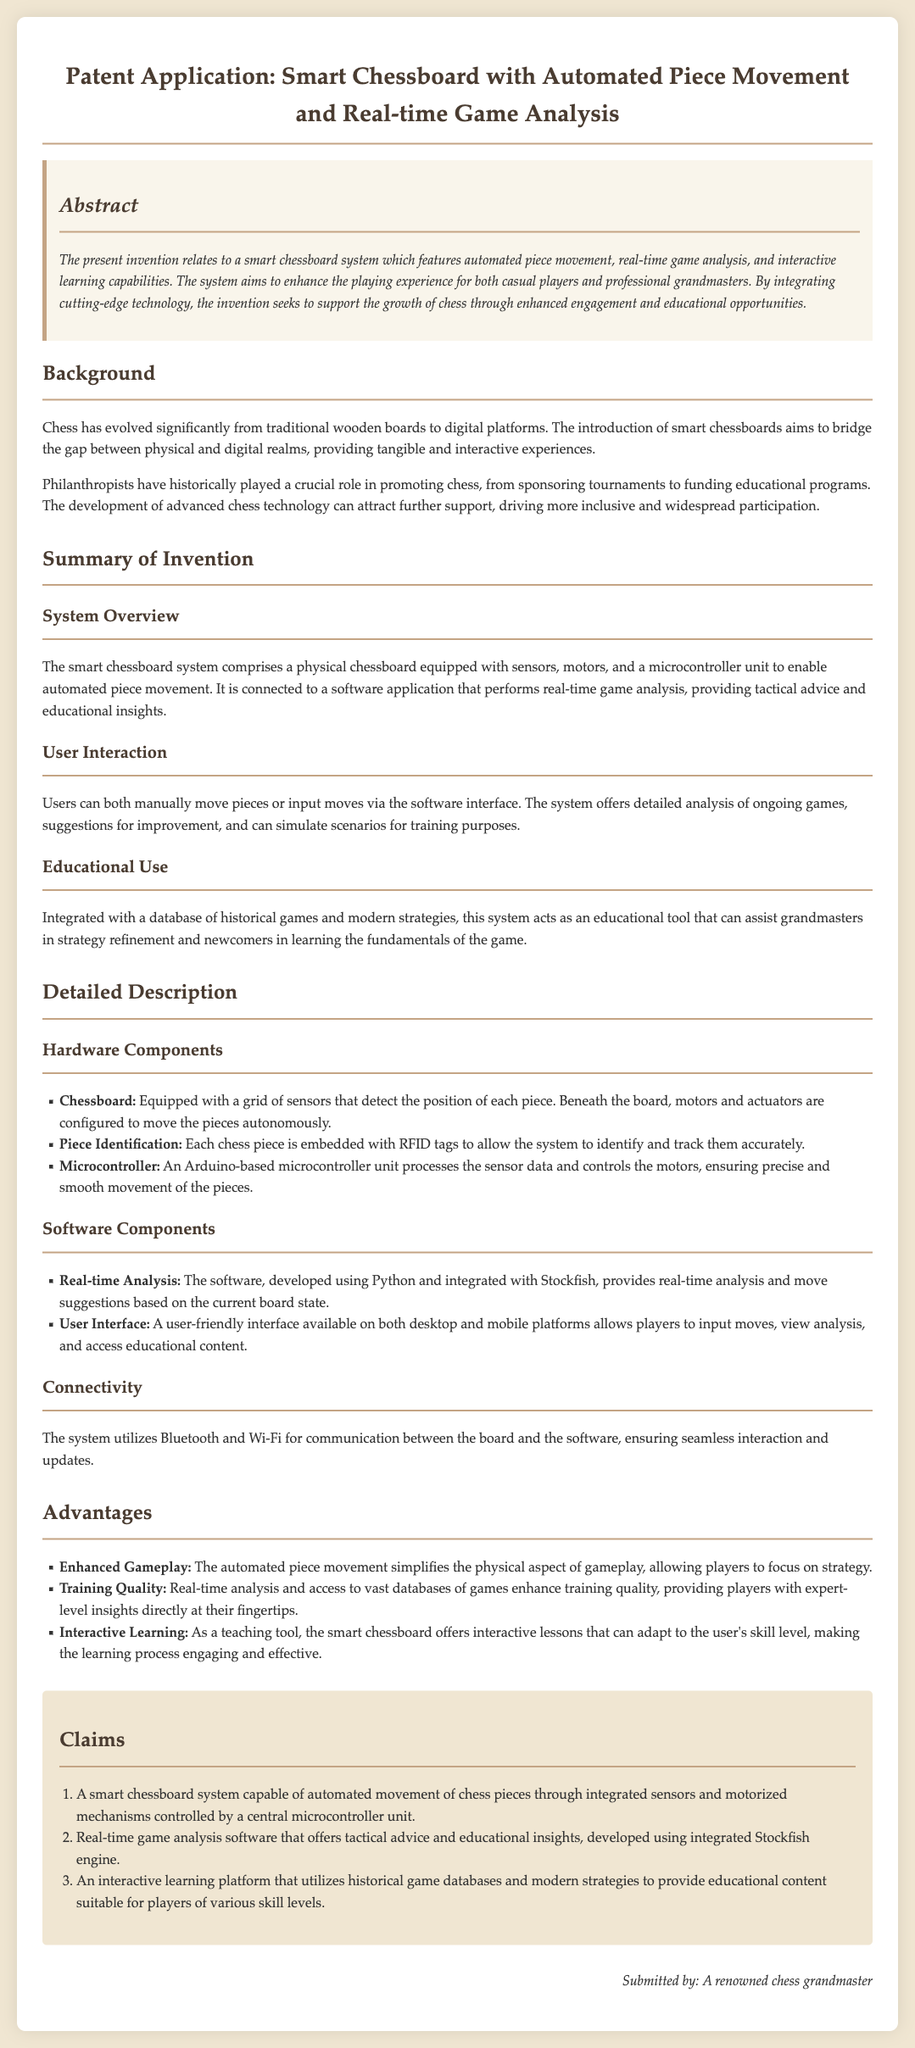What is the title of the patent application? The title of the patent application states the subject matter of the invention.
Answer: Smart Chessboard with Automated Piece Movement and Real-time Game Analysis What technology does the smart chessboard utilize for piece identification? The document specifies how the chess pieces are identified and tracked within the system.
Answer: RFID tags What programming language is the real-time analysis software developed in? This detail reflects the technical choices made for the software components of the invention.
Answer: Python Which component ensures precise movement of the pieces? The document highlights the function of a specific hardware unit crucial for the operation of the chessboard.
Answer: Microcontroller How many claims are included in the patent application? The number of claims reflects the protections sought for the innovations described in the application.
Answer: Three Which feature simplifies the physical aspect of gameplay? This feature represents a significant advantage of the smart chessboard system.
Answer: Automated piece movement What is integrated with the educational tool of the smart chessboard? This aspect of the system supports its function as a learning aid for players.
Answer: Historical games and modern strategies What does the smart chessboard system aim to enhance? The document discusses the primary objective of the system in relation to player experience.
Answer: Playing experience What form of connectivity does the system utilize? This information reveals how the smart chessboard communicates with the software.
Answer: Bluetooth and Wi-Fi 